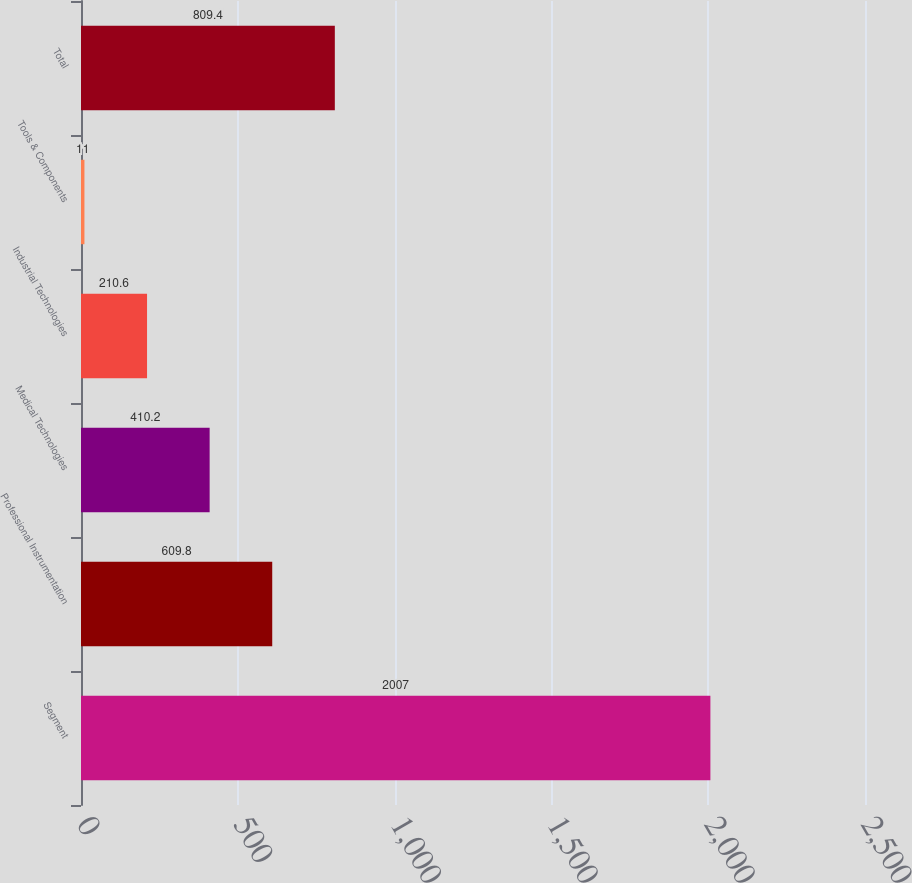Convert chart. <chart><loc_0><loc_0><loc_500><loc_500><bar_chart><fcel>Segment<fcel>Professional Instrumentation<fcel>Medical Technologies<fcel>Industrial Technologies<fcel>Tools & Components<fcel>Total<nl><fcel>2007<fcel>609.8<fcel>410.2<fcel>210.6<fcel>11<fcel>809.4<nl></chart> 